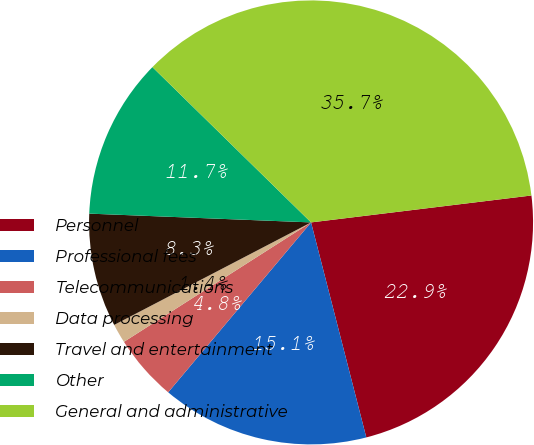Convert chart. <chart><loc_0><loc_0><loc_500><loc_500><pie_chart><fcel>Personnel<fcel>Professional fees<fcel>Telecommunications<fcel>Data processing<fcel>Travel and entertainment<fcel>Other<fcel>General and administrative<nl><fcel>22.93%<fcel>15.13%<fcel>4.83%<fcel>1.4%<fcel>8.27%<fcel>11.7%<fcel>35.73%<nl></chart> 